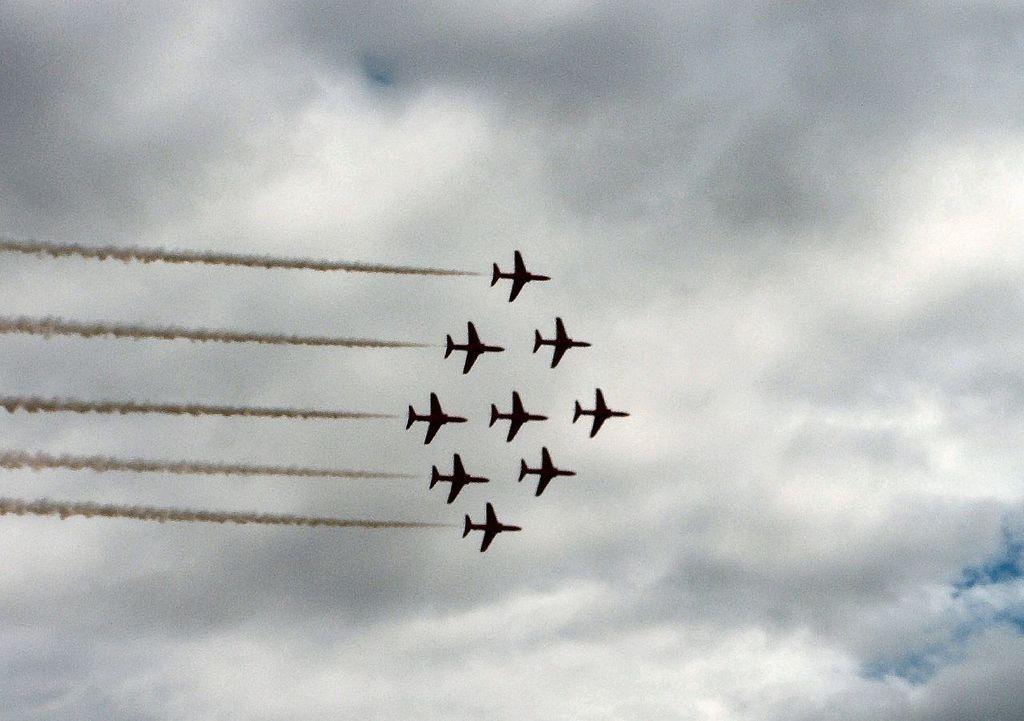Could you give a brief overview of what you see in this image? In this image, we can see planes with smoke in the sky. 